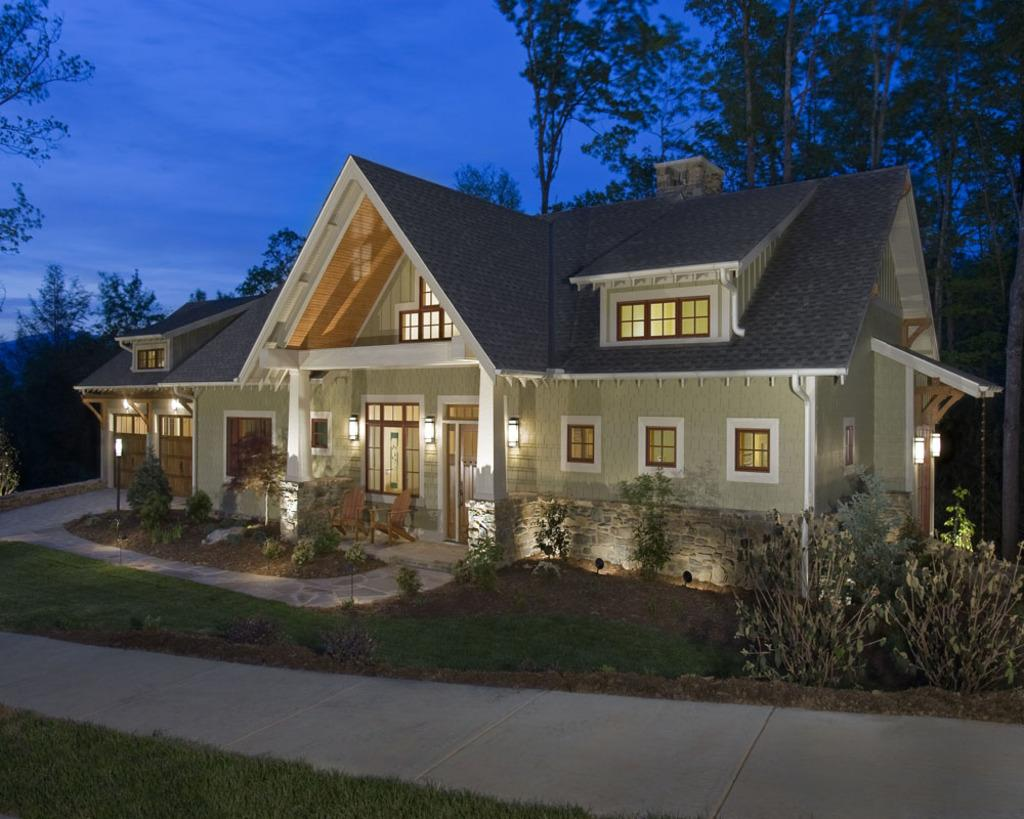What type of terrain is depicted in the image? There is a grassy land in the image. What feature can be seen at the bottom of the image? There is a walkway at the bottom of the image. What type of vegetation is present in the image? Plants and trees are visible in the image. Where is the house located in the image? The house is in the middle of the image. What is visible at the top of the image? The sky is visible at the top of the image. What verse is being recited by the geese in the image? There are no geese present in the image, so there is no verse being recited. What type of house is shown in the image? The provided facts do not specify the type of house, only its location in the middle of the image. 